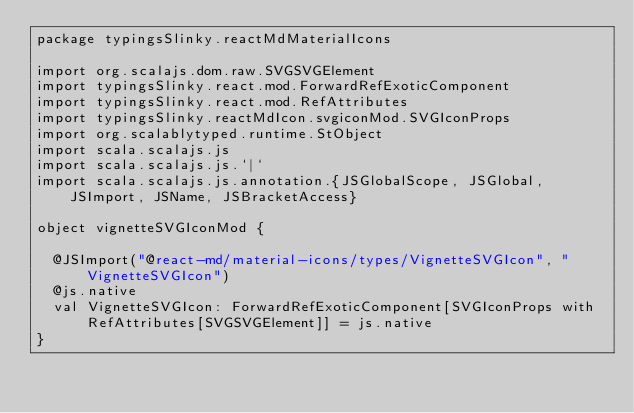Convert code to text. <code><loc_0><loc_0><loc_500><loc_500><_Scala_>package typingsSlinky.reactMdMaterialIcons

import org.scalajs.dom.raw.SVGSVGElement
import typingsSlinky.react.mod.ForwardRefExoticComponent
import typingsSlinky.react.mod.RefAttributes
import typingsSlinky.reactMdIcon.svgiconMod.SVGIconProps
import org.scalablytyped.runtime.StObject
import scala.scalajs.js
import scala.scalajs.js.`|`
import scala.scalajs.js.annotation.{JSGlobalScope, JSGlobal, JSImport, JSName, JSBracketAccess}

object vignetteSVGIconMod {
  
  @JSImport("@react-md/material-icons/types/VignetteSVGIcon", "VignetteSVGIcon")
  @js.native
  val VignetteSVGIcon: ForwardRefExoticComponent[SVGIconProps with RefAttributes[SVGSVGElement]] = js.native
}
</code> 